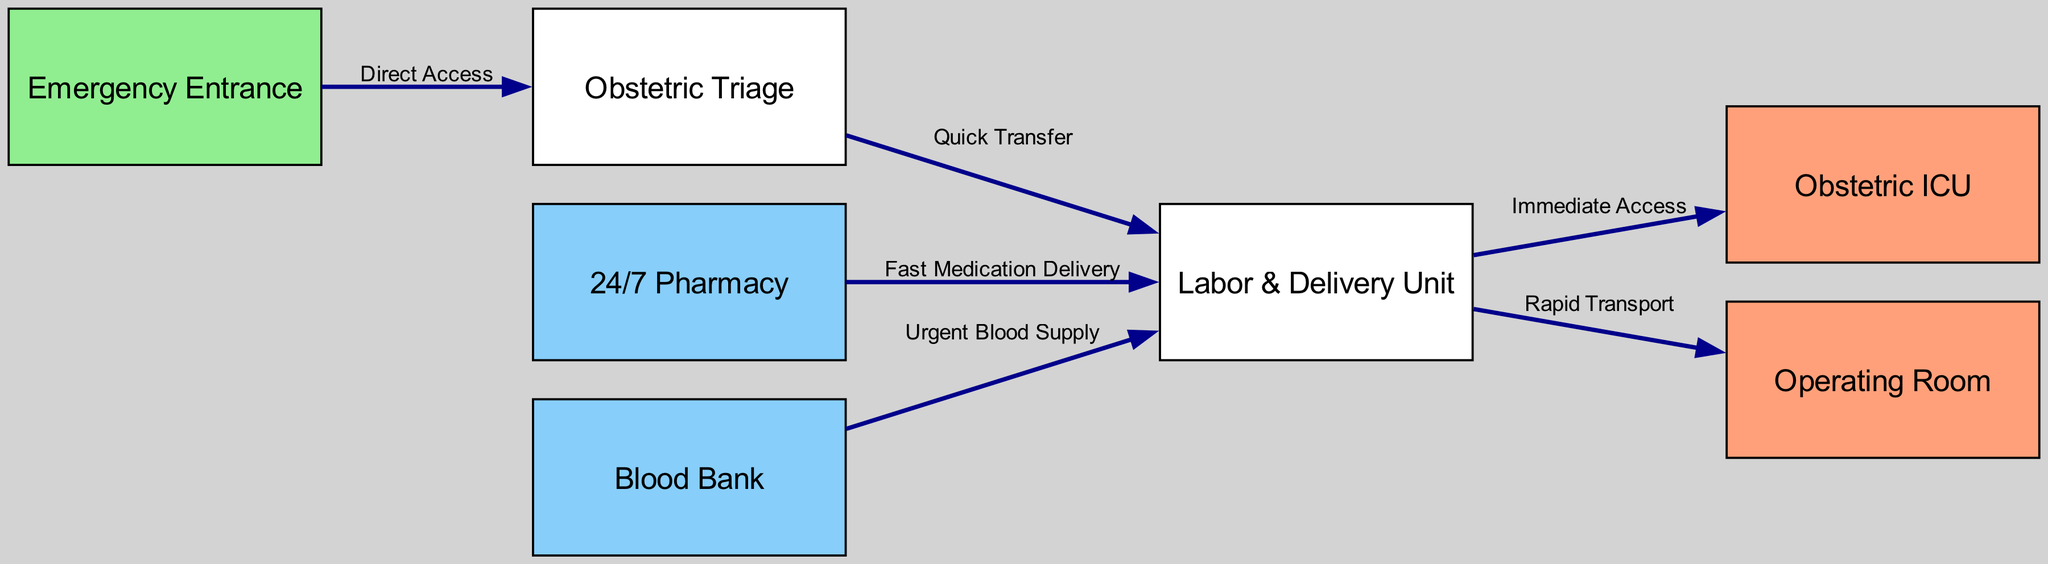What is the first node in the diagram? The first node in the diagram is identified as the "Emergency Entrance," where patients begin their journey in the hospital layout.
Answer: Emergency Entrance How many nodes are present in the diagram? The diagram contains a total of seven nodes, which include the Emergency Entrance, Obstetric Triage, Labor & Delivery Unit, Obstetric ICU, Operating Room, 24/7 Pharmacy, and Blood Bank.
Answer: 7 What type of access is there between the Emergency Entrance and Obstetric Triage? The relationship between the Emergency Entrance and Obstetric Triage is described as "Direct Access," indicating an immediate pathway from entrance to triage.
Answer: Direct Access Which unit has "Immediate Access" from the Labor & Delivery Unit? The unit that has "Immediate Access" from the Labor & Delivery Unit is the Obstetric ICU, as this connection facilitates rapid movement in case of emergencies.
Answer: Obstetric ICU What is the label of the edge connecting Pharmacy to Labor? The edge connecting the Pharmacy to the Labor & Delivery Unit is labeled "Fast Medication Delivery," highlighting the need for timely access to medications.
Answer: Fast Medication Delivery How many edges are used in the diagram? There are six edges depicted in the diagram, representing the pathways of movement and service between the various units.
Answer: 6 Which unit is connected to the Labor & Delivery Unit with a label indicating rapid transport? The unit connected to the Labor & Delivery Unit that denotes rapid transport is the Operating Room, showing a critical route for urgent cases needing surgical intervention.
Answer: Operating Room Which two units have arrows indicating urgent supply and quick response to the Labor & Delivery Unit? The two units that provide urgent supply and quick response to the Labor & Delivery Unit are the Blood Bank and Pharmacy, both vital for any emergency scenarios.
Answer: Blood Bank and Pharmacy What is the relationship type between Triage and Labor? The relationship between Triage and Labor is described as "Quick Transfer," which implies an efficient movement of patients for necessary care.
Answer: Quick Transfer 